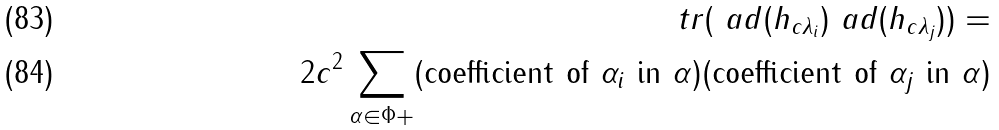<formula> <loc_0><loc_0><loc_500><loc_500>\ t r ( \ a d ( h _ { c \lambda _ { i } } ) \ a d ( h _ { c \lambda _ { j } } ) ) = \\ 2 c ^ { 2 } \sum _ { \alpha \in \Phi + } ( \text {coefficient of $\alpha_{i}$ in $\alpha$} ) ( \text {coefficient of $\alpha_{j}$ in $\alpha$} )</formula> 